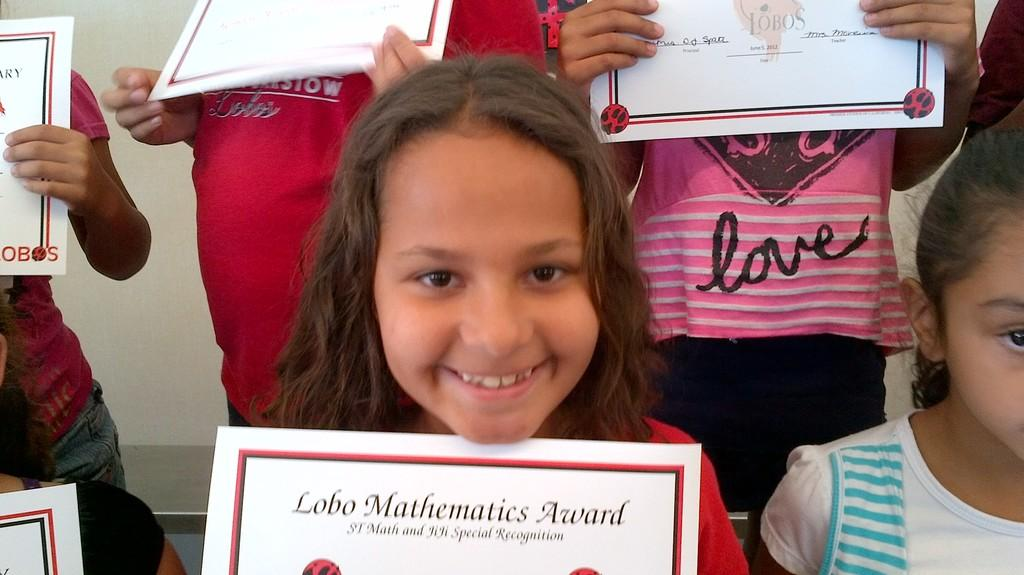How many people are in the image? There are many people in the image. What are the people holding in the image? The people are holding certificates. What can be seen in the background of the image? There is a wall in the background of the image. What type of pollution is visible in the image? There is no pollution visible in the image. How many yokes are being used by the people in the image? There are no yokes present in the image. 